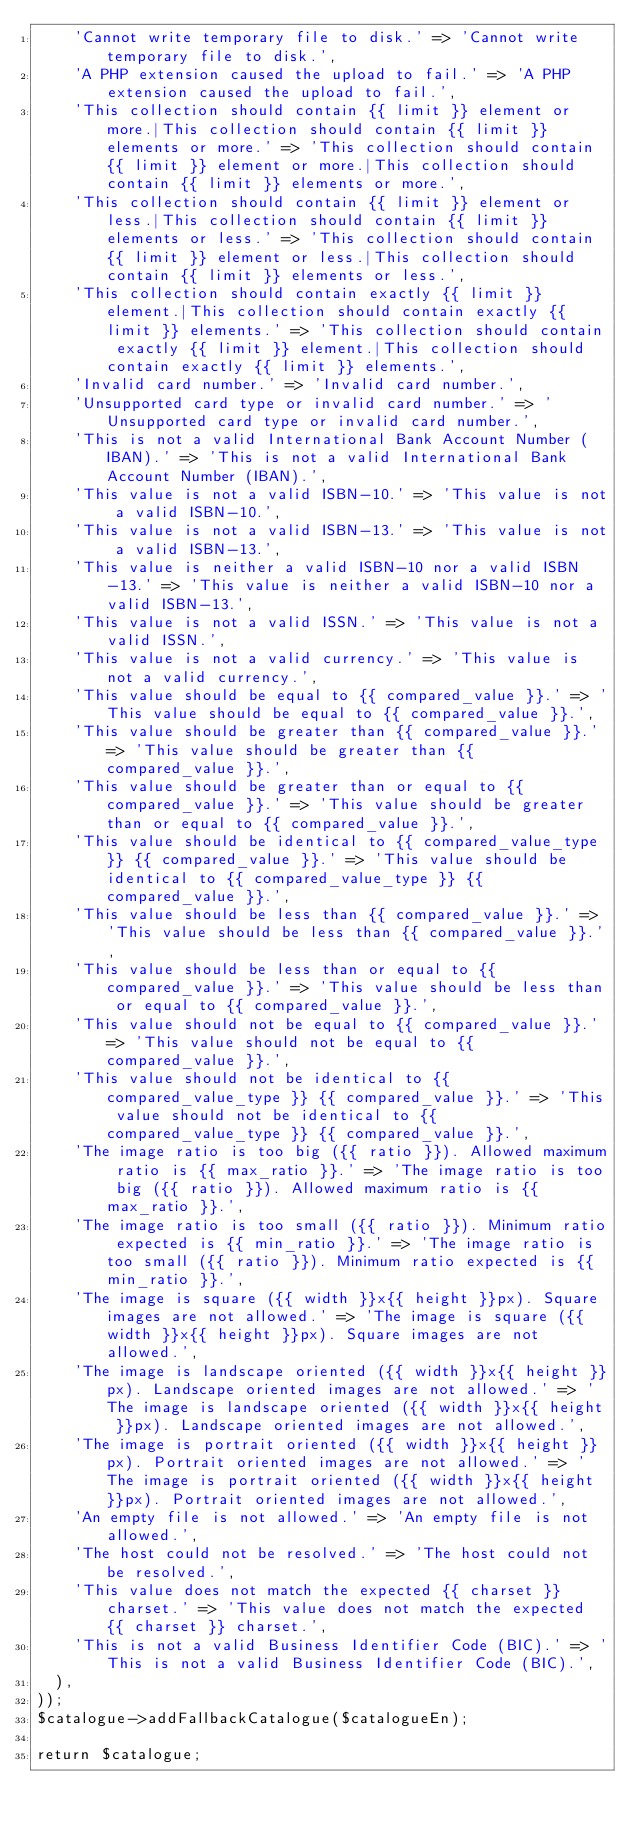Convert code to text. <code><loc_0><loc_0><loc_500><loc_500><_PHP_>    'Cannot write temporary file to disk.' => 'Cannot write temporary file to disk.',
    'A PHP extension caused the upload to fail.' => 'A PHP extension caused the upload to fail.',
    'This collection should contain {{ limit }} element or more.|This collection should contain {{ limit }} elements or more.' => 'This collection should contain {{ limit }} element or more.|This collection should contain {{ limit }} elements or more.',
    'This collection should contain {{ limit }} element or less.|This collection should contain {{ limit }} elements or less.' => 'This collection should contain {{ limit }} element or less.|This collection should contain {{ limit }} elements or less.',
    'This collection should contain exactly {{ limit }} element.|This collection should contain exactly {{ limit }} elements.' => 'This collection should contain exactly {{ limit }} element.|This collection should contain exactly {{ limit }} elements.',
    'Invalid card number.' => 'Invalid card number.',
    'Unsupported card type or invalid card number.' => 'Unsupported card type or invalid card number.',
    'This is not a valid International Bank Account Number (IBAN).' => 'This is not a valid International Bank Account Number (IBAN).',
    'This value is not a valid ISBN-10.' => 'This value is not a valid ISBN-10.',
    'This value is not a valid ISBN-13.' => 'This value is not a valid ISBN-13.',
    'This value is neither a valid ISBN-10 nor a valid ISBN-13.' => 'This value is neither a valid ISBN-10 nor a valid ISBN-13.',
    'This value is not a valid ISSN.' => 'This value is not a valid ISSN.',
    'This value is not a valid currency.' => 'This value is not a valid currency.',
    'This value should be equal to {{ compared_value }}.' => 'This value should be equal to {{ compared_value }}.',
    'This value should be greater than {{ compared_value }}.' => 'This value should be greater than {{ compared_value }}.',
    'This value should be greater than or equal to {{ compared_value }}.' => 'This value should be greater than or equal to {{ compared_value }}.',
    'This value should be identical to {{ compared_value_type }} {{ compared_value }}.' => 'This value should be identical to {{ compared_value_type }} {{ compared_value }}.',
    'This value should be less than {{ compared_value }}.' => 'This value should be less than {{ compared_value }}.',
    'This value should be less than or equal to {{ compared_value }}.' => 'This value should be less than or equal to {{ compared_value }}.',
    'This value should not be equal to {{ compared_value }}.' => 'This value should not be equal to {{ compared_value }}.',
    'This value should not be identical to {{ compared_value_type }} {{ compared_value }}.' => 'This value should not be identical to {{ compared_value_type }} {{ compared_value }}.',
    'The image ratio is too big ({{ ratio }}). Allowed maximum ratio is {{ max_ratio }}.' => 'The image ratio is too big ({{ ratio }}). Allowed maximum ratio is {{ max_ratio }}.',
    'The image ratio is too small ({{ ratio }}). Minimum ratio expected is {{ min_ratio }}.' => 'The image ratio is too small ({{ ratio }}). Minimum ratio expected is {{ min_ratio }}.',
    'The image is square ({{ width }}x{{ height }}px). Square images are not allowed.' => 'The image is square ({{ width }}x{{ height }}px). Square images are not allowed.',
    'The image is landscape oriented ({{ width }}x{{ height }}px). Landscape oriented images are not allowed.' => 'The image is landscape oriented ({{ width }}x{{ height }}px). Landscape oriented images are not allowed.',
    'The image is portrait oriented ({{ width }}x{{ height }}px). Portrait oriented images are not allowed.' => 'The image is portrait oriented ({{ width }}x{{ height }}px). Portrait oriented images are not allowed.',
    'An empty file is not allowed.' => 'An empty file is not allowed.',
    'The host could not be resolved.' => 'The host could not be resolved.',
    'This value does not match the expected {{ charset }} charset.' => 'This value does not match the expected {{ charset }} charset.',
    'This is not a valid Business Identifier Code (BIC).' => 'This is not a valid Business Identifier Code (BIC).',
  ),
));
$catalogue->addFallbackCatalogue($catalogueEn);

return $catalogue;
</code> 